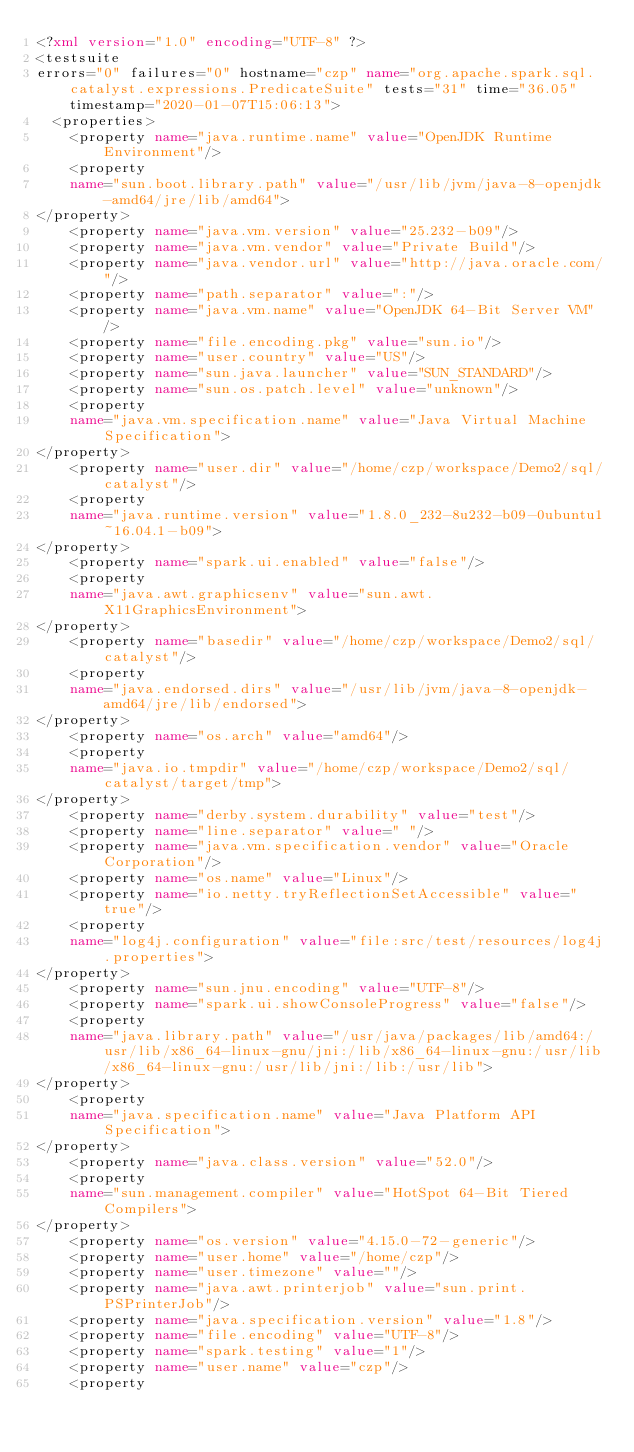Convert code to text. <code><loc_0><loc_0><loc_500><loc_500><_XML_><?xml version="1.0" encoding="UTF-8" ?>
<testsuite 
errors="0" failures="0" hostname="czp" name="org.apache.spark.sql.catalyst.expressions.PredicateSuite" tests="31" time="36.05" timestamp="2020-01-07T15:06:13">
  <properties>
    <property name="java.runtime.name" value="OpenJDK Runtime Environment"/>
    <property 
    name="sun.boot.library.path" value="/usr/lib/jvm/java-8-openjdk-amd64/jre/lib/amd64">
</property>
    <property name="java.vm.version" value="25.232-b09"/>
    <property name="java.vm.vendor" value="Private Build"/>
    <property name="java.vendor.url" value="http://java.oracle.com/"/>
    <property name="path.separator" value=":"/>
    <property name="java.vm.name" value="OpenJDK 64-Bit Server VM"/>
    <property name="file.encoding.pkg" value="sun.io"/>
    <property name="user.country" value="US"/>
    <property name="sun.java.launcher" value="SUN_STANDARD"/>
    <property name="sun.os.patch.level" value="unknown"/>
    <property 
    name="java.vm.specification.name" value="Java Virtual Machine Specification">
</property>
    <property name="user.dir" value="/home/czp/workspace/Demo2/sql/catalyst"/>
    <property 
    name="java.runtime.version" value="1.8.0_232-8u232-b09-0ubuntu1~16.04.1-b09">
</property>
    <property name="spark.ui.enabled" value="false"/>
    <property 
    name="java.awt.graphicsenv" value="sun.awt.X11GraphicsEnvironment">
</property>
    <property name="basedir" value="/home/czp/workspace/Demo2/sql/catalyst"/>
    <property 
    name="java.endorsed.dirs" value="/usr/lib/jvm/java-8-openjdk-amd64/jre/lib/endorsed">
</property>
    <property name="os.arch" value="amd64"/>
    <property 
    name="java.io.tmpdir" value="/home/czp/workspace/Demo2/sql/catalyst/target/tmp">
</property>
    <property name="derby.system.durability" value="test"/>
    <property name="line.separator" value=" "/>
    <property name="java.vm.specification.vendor" value="Oracle Corporation"/>
    <property name="os.name" value="Linux"/>
    <property name="io.netty.tryReflectionSetAccessible" value="true"/>
    <property 
    name="log4j.configuration" value="file:src/test/resources/log4j.properties">
</property>
    <property name="sun.jnu.encoding" value="UTF-8"/>
    <property name="spark.ui.showConsoleProgress" value="false"/>
    <property 
    name="java.library.path" value="/usr/java/packages/lib/amd64:/usr/lib/x86_64-linux-gnu/jni:/lib/x86_64-linux-gnu:/usr/lib/x86_64-linux-gnu:/usr/lib/jni:/lib:/usr/lib">
</property>
    <property 
    name="java.specification.name" value="Java Platform API Specification">
</property>
    <property name="java.class.version" value="52.0"/>
    <property 
    name="sun.management.compiler" value="HotSpot 64-Bit Tiered Compilers">
</property>
    <property name="os.version" value="4.15.0-72-generic"/>
    <property name="user.home" value="/home/czp"/>
    <property name="user.timezone" value=""/>
    <property name="java.awt.printerjob" value="sun.print.PSPrinterJob"/>
    <property name="java.specification.version" value="1.8"/>
    <property name="file.encoding" value="UTF-8"/>
    <property name="spark.testing" value="1"/>
    <property name="user.name" value="czp"/>
    <property </code> 